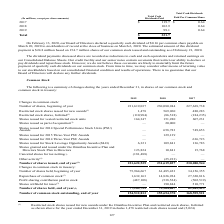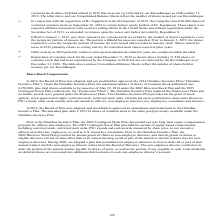According to Sealed Air Corporation's financial document, What does the table show? summary of changes during the years ended December 31, in shares of our common stock and common stock in treasury. The document states: "The following is a summary of changes during the years ended December 31, in shares of our common stock and common stock in treasury:..." Also, What does the Repurchase of common stock for the year ended December 31, 2019 as shown above include that is not yet reflected by the Recordkeeper as of December 31, 2018? 71,530 shares of common stock that had been repurchased by the Company in 2018. The document states: "r ended December 31, 2019 as shown above includes 71,530 shares of common stock that had been repurchased by the Company in 2018 but not yet reflected..." Also, What is the Number of common stock outstanding, end of year for 2019? According to the financial document, 154,512,813. The relevant text states: "Number of common stock outstanding, end of year 154,512,813 155,654,370 168,595,521..." Also, can you calculate: What is the Number of shares held, end of year expressed as a percentage of Number of common stock outstanding, end of year? Based on the calculation: 77,109,722/154,512,813, the result is 49.91 (percentage). This is based on the information: "Number of common stock outstanding, end of year 154,512,813 155,654,370 168,595,521 Number of shares held, end of year (5) 77,109,722 75,964,667 61,485,423..." The key data points involved are: 154,512,813, 77,109,722. Also, can you calculate: What is the percentage change of the Number of shares held, end of year from 2017 to 2018? To answer this question, I need to perform calculations using the financial data. The calculation is: (75,964,667-61,485,423)/61,485,423, which equals 23.55 (percentage). This is based on the information: "Number of shares held, beginning of year 75,964,667 61,485,423 34,156,355 mber of shares held, beginning of year 75,964,667 61,485,423 34,156,355..." The key data points involved are: 61,485,423, 75,964,667. Also, can you calculate: What is the number of shares issued, end of year excluding 1,478 restricted stock shares issued and (5,024) restricted stock shares for 2019? Based on the calculation: 231,622,535-(1,478-(-5,024)), the result is 231616033. This is based on the information: "Number of shares issued, end of year (1) 231,622,535 231,619,037 230,080,944 Restricted stock shares issued for new awards (1) 1,478 569,960 480,283 Restricted stock shares issued for new awards (1) 1..." The key data points involved are: 1,478, 231,622,535, 5,024. 